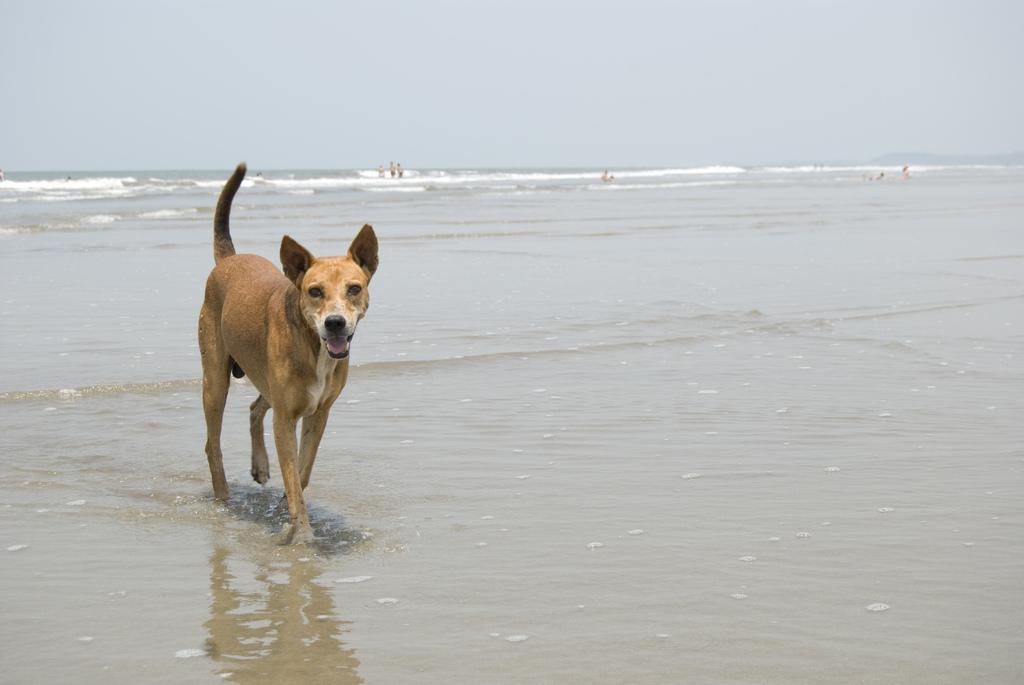What is the main subject in the center of the image? There is a dog in the center of the image. Can you describe the appearance of the dog? The dog is brown in color. What can be seen in the background of the image? There is sky and water visible in the background of the image. Are there any other living beings in the image? Yes, there are people in the background of the image. How many fangs does the dog have in the image? The image does not show the dog's teeth, so it is impossible to determine the number of fangs. What type of border surrounds the water in the image? There is no border visible around the water in the image. 